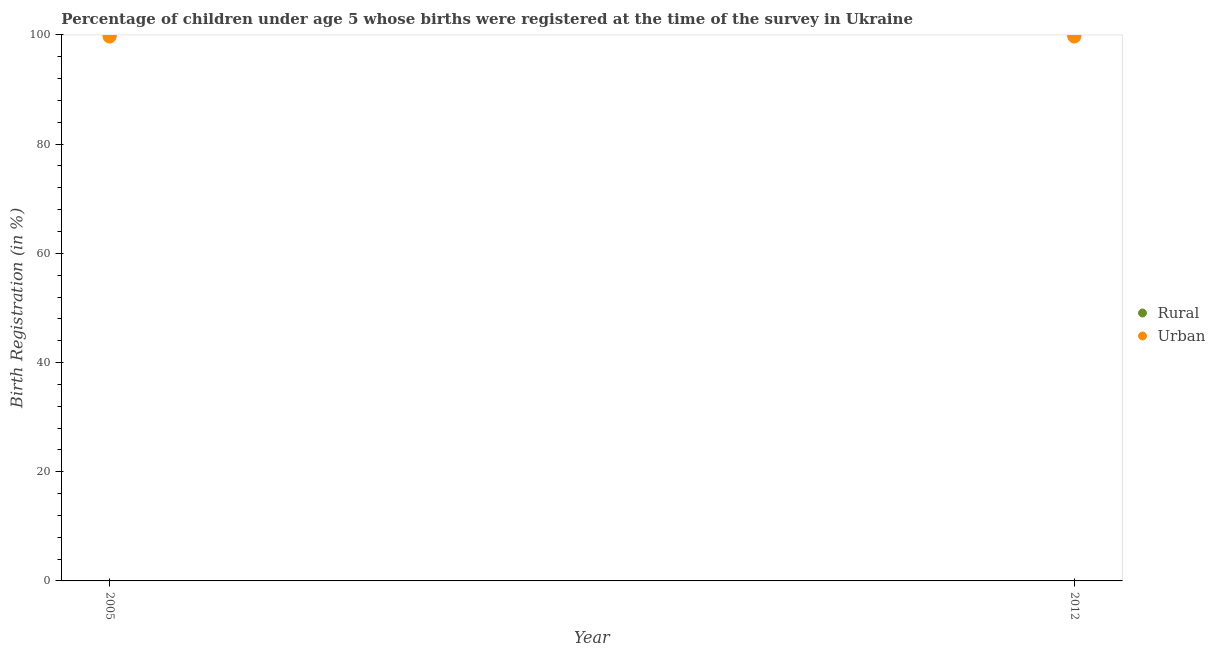How many different coloured dotlines are there?
Keep it short and to the point. 2. What is the urban birth registration in 2012?
Provide a succinct answer. 99.7. Across all years, what is the maximum rural birth registration?
Offer a very short reply. 100. Across all years, what is the minimum urban birth registration?
Provide a short and direct response. 99.7. In which year was the rural birth registration maximum?
Your answer should be very brief. 2005. In which year was the urban birth registration minimum?
Give a very brief answer. 2005. What is the total urban birth registration in the graph?
Offer a very short reply. 199.4. What is the difference between the rural birth registration in 2012 and the urban birth registration in 2005?
Give a very brief answer. 0.3. What is the average urban birth registration per year?
Your response must be concise. 99.7. In the year 2012, what is the difference between the rural birth registration and urban birth registration?
Your answer should be very brief. 0.3. In how many years, is the rural birth registration greater than 4 %?
Make the answer very short. 2. Is the urban birth registration strictly greater than the rural birth registration over the years?
Offer a very short reply. No. Is the rural birth registration strictly less than the urban birth registration over the years?
Provide a succinct answer. No. How many dotlines are there?
Your answer should be compact. 2. Are the values on the major ticks of Y-axis written in scientific E-notation?
Give a very brief answer. No. Does the graph contain grids?
Offer a terse response. No. Where does the legend appear in the graph?
Offer a very short reply. Center right. How are the legend labels stacked?
Give a very brief answer. Vertical. What is the title of the graph?
Your answer should be very brief. Percentage of children under age 5 whose births were registered at the time of the survey in Ukraine. Does "From Government" appear as one of the legend labels in the graph?
Make the answer very short. No. What is the label or title of the X-axis?
Your response must be concise. Year. What is the label or title of the Y-axis?
Provide a succinct answer. Birth Registration (in %). What is the Birth Registration (in %) in Rural in 2005?
Offer a very short reply. 100. What is the Birth Registration (in %) in Urban in 2005?
Your answer should be compact. 99.7. What is the Birth Registration (in %) in Urban in 2012?
Ensure brevity in your answer.  99.7. Across all years, what is the maximum Birth Registration (in %) of Rural?
Give a very brief answer. 100. Across all years, what is the maximum Birth Registration (in %) in Urban?
Ensure brevity in your answer.  99.7. Across all years, what is the minimum Birth Registration (in %) of Rural?
Keep it short and to the point. 100. Across all years, what is the minimum Birth Registration (in %) in Urban?
Provide a succinct answer. 99.7. What is the total Birth Registration (in %) in Rural in the graph?
Provide a succinct answer. 200. What is the total Birth Registration (in %) of Urban in the graph?
Offer a terse response. 199.4. What is the difference between the Birth Registration (in %) in Rural in 2005 and the Birth Registration (in %) in Urban in 2012?
Make the answer very short. 0.3. What is the average Birth Registration (in %) of Rural per year?
Offer a very short reply. 100. What is the average Birth Registration (in %) of Urban per year?
Your answer should be compact. 99.7. In the year 2005, what is the difference between the Birth Registration (in %) in Rural and Birth Registration (in %) in Urban?
Your answer should be very brief. 0.3. What is the difference between the highest and the second highest Birth Registration (in %) of Rural?
Offer a terse response. 0. What is the difference between the highest and the second highest Birth Registration (in %) in Urban?
Offer a terse response. 0. 